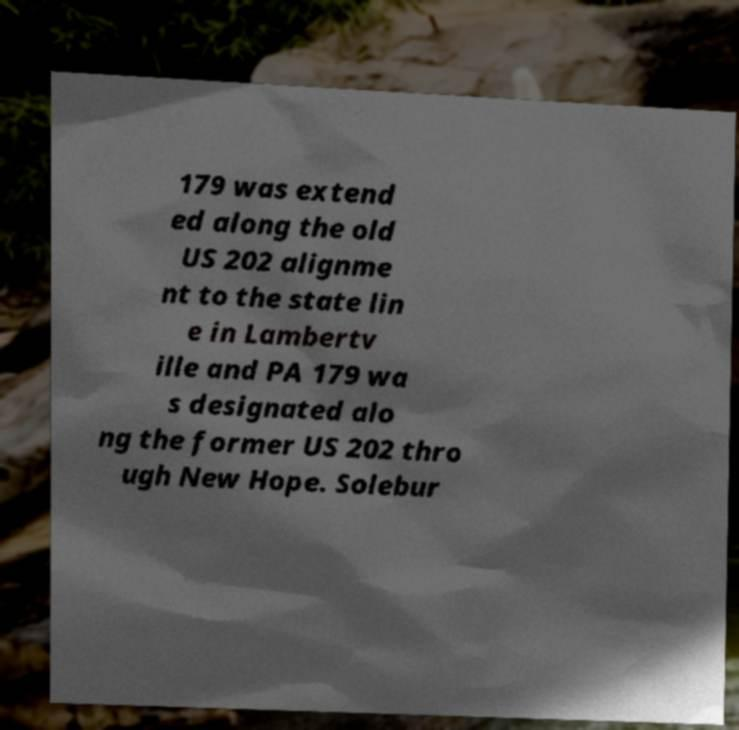Please identify and transcribe the text found in this image. 179 was extend ed along the old US 202 alignme nt to the state lin e in Lambertv ille and PA 179 wa s designated alo ng the former US 202 thro ugh New Hope. Solebur 